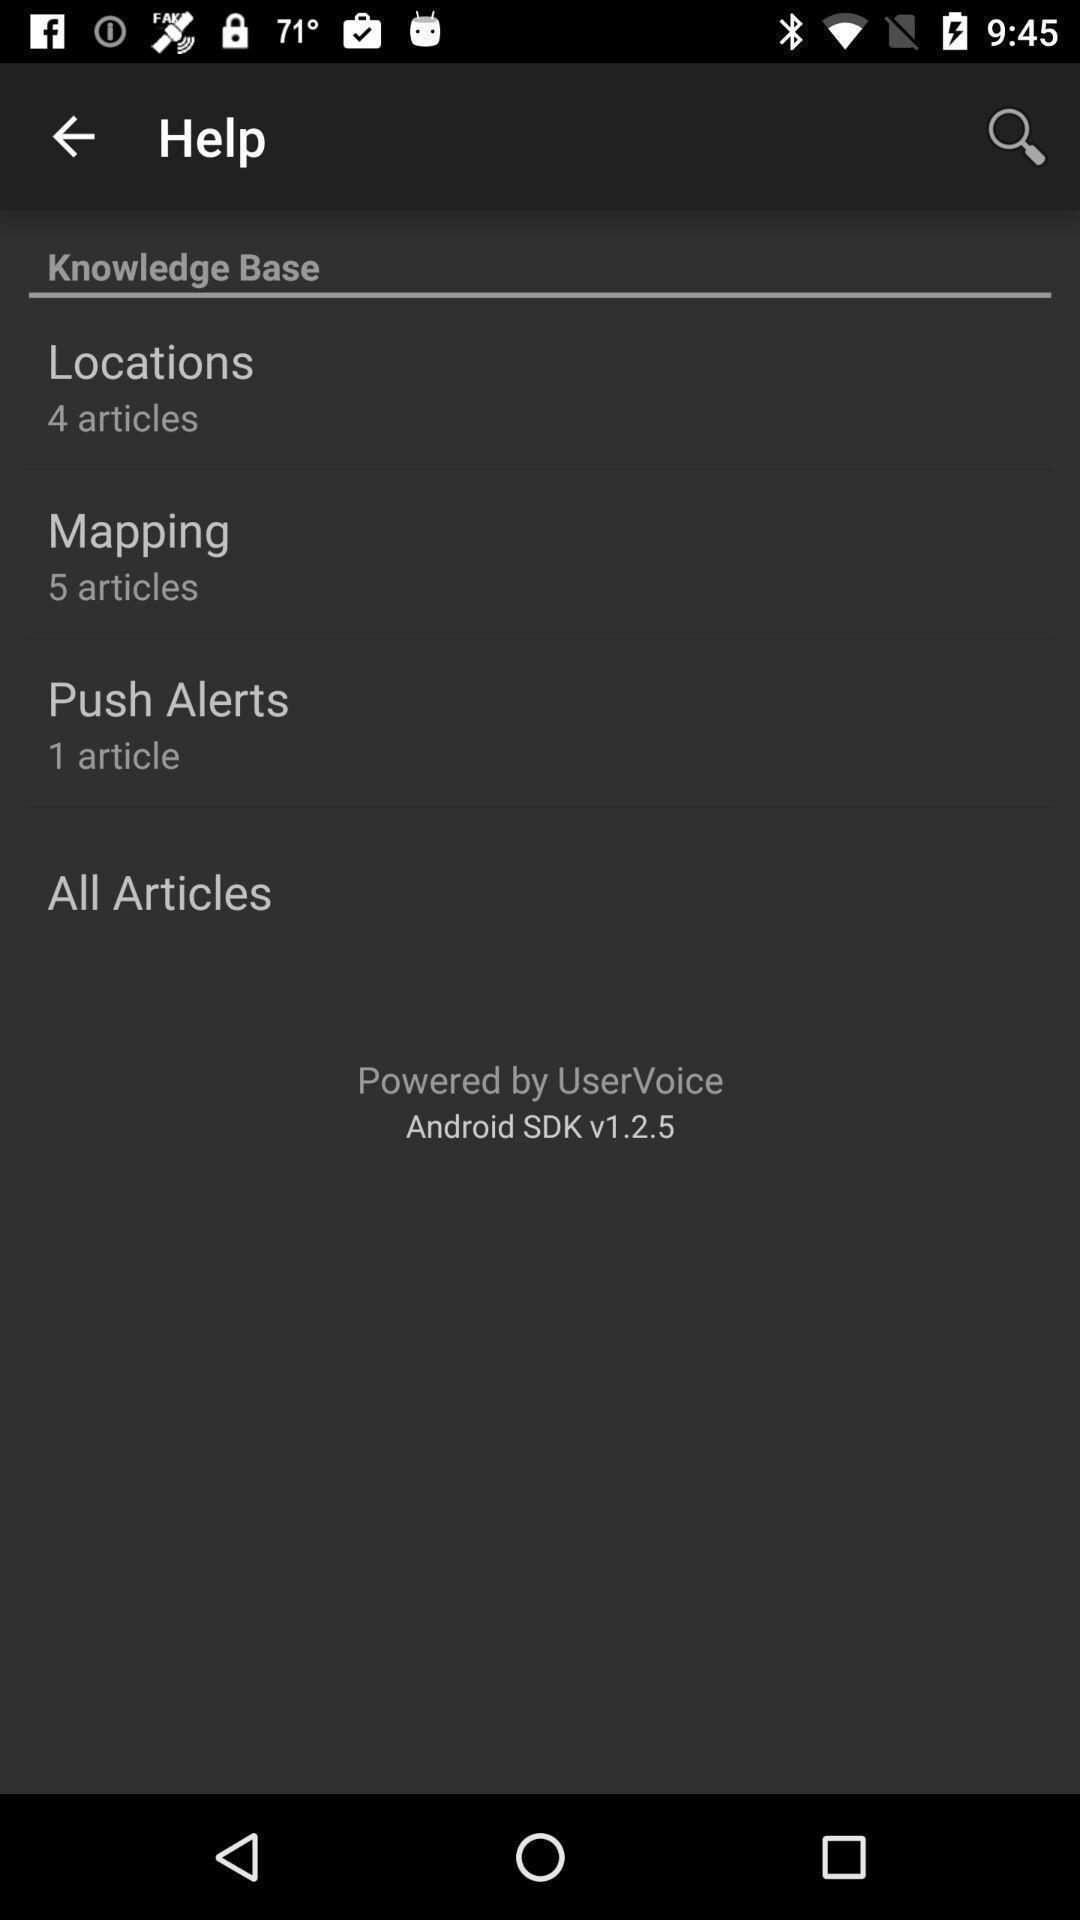What can you discern from this picture? Screen is showing help page. 